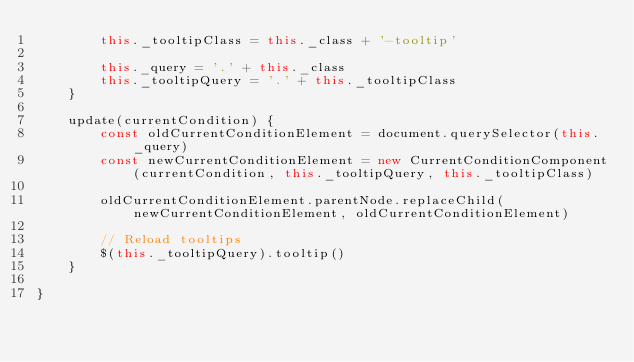<code> <loc_0><loc_0><loc_500><loc_500><_JavaScript_>        this._tooltipClass = this._class + '-tooltip'

        this._query = '.' + this._class
        this._tooltipQuery = '.' + this._tooltipClass
    }

    update(currentCondition) {
        const oldCurrentConditionElement = document.querySelector(this._query)
        const newCurrentConditionElement = new CurrentConditionComponent(currentCondition, this._tooltipQuery, this._tooltipClass)

        oldCurrentConditionElement.parentNode.replaceChild(newCurrentConditionElement, oldCurrentConditionElement)

        // Reload tooltips
        $(this._tooltipQuery).tooltip()
    }

}
</code> 